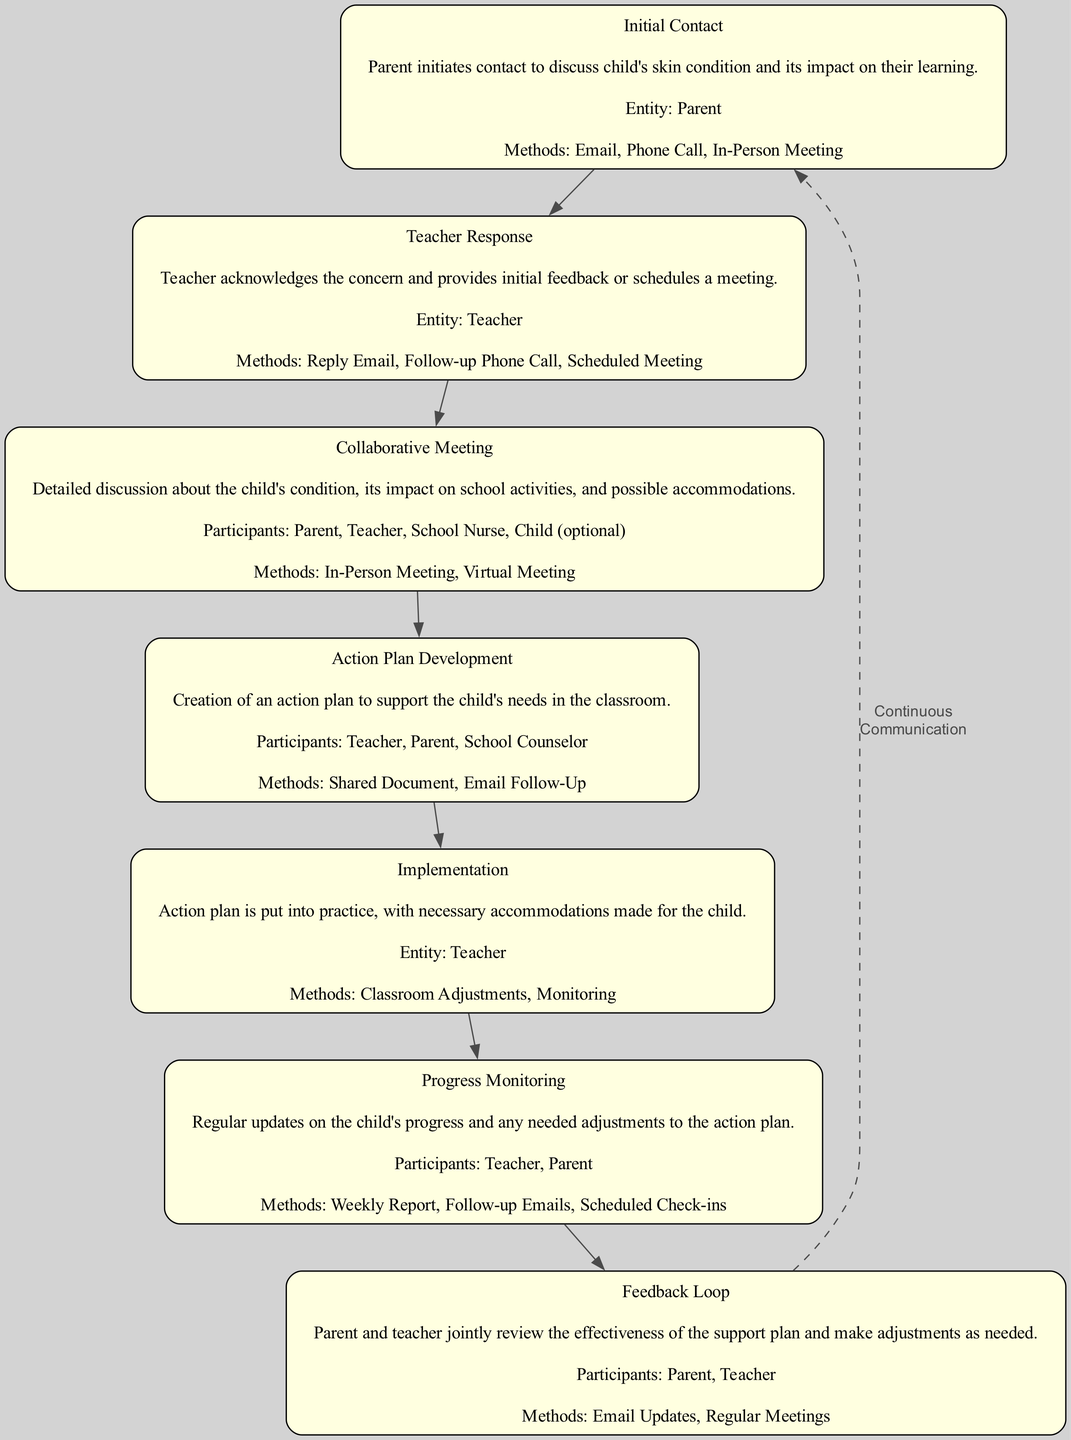What is the first step in the Parent-Teacher Communication Cycle? The diagram shows "Initial Contact" as the first step, which is where the parent initiates contact regarding the child's skin condition.
Answer: Initial Contact How many methods are listed under the "Teacher Response" node? The "Teacher Response" node includes three methods: "Reply Email," "Follow-up Phone Call," and "Scheduled Meeting." Thus, the total count of methods is three.
Answer: 3 Which participants are involved in the "Collaborative Meeting"? The "Collaborative Meeting" node lists the participants as "Parent," "Teacher," "School Nurse," and "Child (optional)." Therefore, there are four participants involved.
Answer: Parent, Teacher, School Nurse, Child (optional) What method is used in the "Implementation" step? The "Implementation" step includes methods like "Classroom Adjustments" and "Monitoring," indicating that these measures are put into practice for supporting the child.
Answer: Classroom Adjustments, Monitoring What is the relationship between "Progress Monitoring" and "Feedback Loop"? "Progress Monitoring" is followed by "Feedback Loop" in the diagram, indicating that after progress updates, a review of the support plan occurs, creating a flow from one phase to the next.
Answer: Progress Monitoring to Feedback Loop How many steps are there in the Parent-Teacher Communication Cycle? The diagram enumerates seven distinct steps, showcasing the entirety of the communication cycle between parents and teachers.
Answer: 7 What is the last step before continuous communication in the cycle? The last step leading to continuous communication is "Feedback Loop," as the diagram concludes the sequential flow with this step before indicating ongoing dialogue.
Answer: Feedback Loop Which entity is primarily responsible for implementing the action plan? The "Implementation" node clearly states the entity responsible is the "Teacher" who is tasked with executing the action plan in the classroom.
Answer: Teacher 